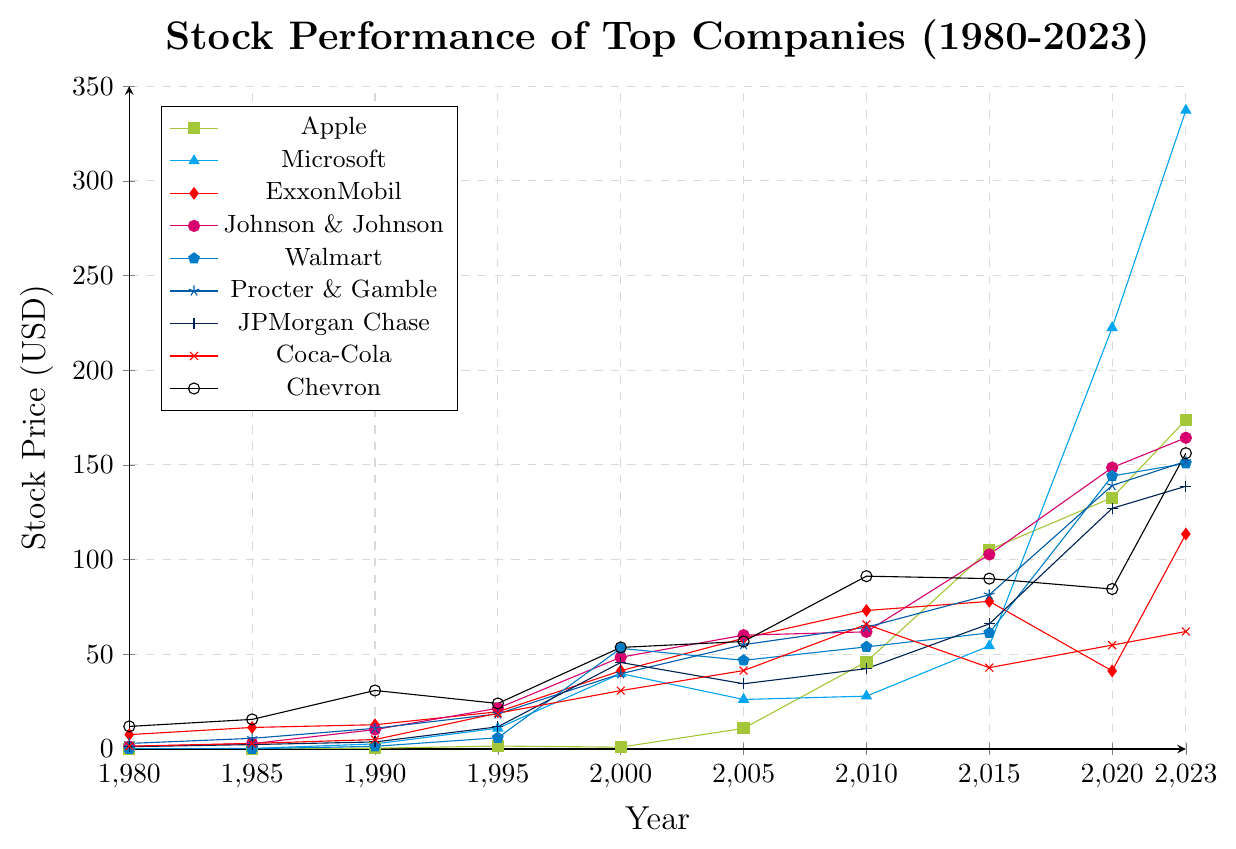What year did Microsoft surpass the 100 USD mark in stock price? According to the figure, Microsoft surpassed the 100 USD mark around 2015. The stock price was represented visually crossing the 100 USD line between 2020 and 2015.
Answer: 2015 Which company had the highest stock price in 2023? Examining the figure, the company with the highest stock price in 2023 has a marker at the topmost position on the y-axis for the year 2023. Microsoft, represented with a triangle marker, has the highest stock price among the companies in 2023.
Answer: Microsoft How many companies had a stock price less than 50 USD in 1990? Observing the figure for the year 1990 and counting the companies with markers below the 50 USD line, we find that Apple, Microsoft, Walmart, Johnson & Johnson, JPMorgan Chase, and Coca-Cola all had stock prices under 50 USD, totaling six companies.
Answer: 6 Between 2010 and 2020, which company's stock price grew the most in absolute terms? Subtracting each company’s stock price in 2010 from its stock price in 2020 and comparing the differences: 
- Apple: 132.69 - 46.08 = 86.61 
- Microsoft: 222.42 - 27.91 = 194.51 
- ExxonMobil: 41.22 - 73.12 = -31.90 
- Johnson & Johnson: 148.59 - 61.85 = 86.74 
- Walmart: 144.15 - 53.93 = 90.22 
- Procter & Gamble: 139.14 - 64.33 = 74.81 
- JPMorgan Chase: 127.07 - 42.42 = 84.65 
- Coca-Cola: 54.84 - 65.77 = -10.93 
- Chevron: 84.45 - 91.25 = -6.80
Microsoft has the highest absolute growth, increasing by 194.51 USD.
Answer: Microsoft Which company showed a noticeable decline in stock price from 2015 to 2020? Looking at the figure between 2015 and 2020, ExxonMobil's stock price decreased from 77.95 to 41.22, visually showing a downward trend in stock price.
Answer: ExxonMobil Is the average stock price of Apple higher in the second half of the timeline (year 2000 onward) than in the first half (before 2000)? Calculate the average for each period:
- 1980-2000: (0.11 + 0.19 + 0.41 + 1.55 + 0.97) / 5 = 0.646
- 2000-2023: (10.90 + 46.08 + 105.26 + 132.69 + 173.75) / 5 = 93.336 
The average stock price of Apple is much higher in the second half.
Answer: Yes Which companies had their highest stock price in the final year, 2023? By closely examining the highest points for each company in the figure, we see that Apple, Microsoft, ExxonMobil, Johnson & Johnson, Walmart, Procter & Gamble, JPMorgan Chase, and Chevron all had their highest stock price in 2023.
Answer: Eight companies What was the percentage increase in Johnson & Johnson's stock price from 1980 to 2023? Calculating the percentage increase: 
\[
\frac{164.32 - 1.31}{1.31} \times 100 = 12442.75\% 
\]
Johnson & Johnson's stock price increased by a considerable 12442.75%.
Answer: 12442.75% Which company had the least change in stock price over the entire timeline? By analyzing the overall change in stock prices, Coca-Cola appears to have one of the smallest changes from 1.49 in 1980 to 62.03 in 2023. Other companies show larger changes.
Answer: Coca-Cola 